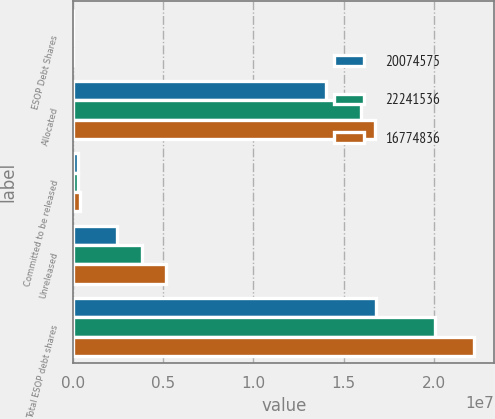Convert chart to OTSL. <chart><loc_0><loc_0><loc_500><loc_500><stacked_bar_chart><ecel><fcel>ESOP Debt Shares<fcel>Allocated<fcel>Committed to be released<fcel>Unreleased<fcel>Total ESOP debt shares<nl><fcel>2.00746e+07<fcel>2007<fcel>1.40391e+07<fcel>278125<fcel>2.45764e+06<fcel>1.67748e+07<nl><fcel>2.22415e+07<fcel>2006<fcel>1.59565e+07<fcel>286620<fcel>3.83142e+06<fcel>2.00746e+07<nl><fcel>1.67748e+07<fcel>2005<fcel>1.67295e+07<fcel>366969<fcel>5.14504e+06<fcel>2.22415e+07<nl></chart> 